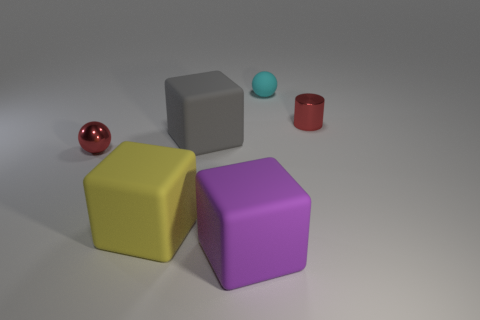Are there the same number of small cylinders left of the large yellow matte object and small red metal balls?
Give a very brief answer. No. What number of yellow matte cubes are to the right of the shiny object on the right side of the red object to the left of the small cyan thing?
Provide a succinct answer. 0. What color is the small object behind the red metal cylinder?
Offer a very short reply. Cyan. There is a block that is both to the right of the yellow matte thing and behind the purple object; what is its material?
Ensure brevity in your answer.  Rubber. There is a small rubber ball behind the big purple matte object; how many cylinders are in front of it?
Offer a very short reply. 1. The big yellow thing has what shape?
Offer a very short reply. Cube. What is the shape of the purple thing that is the same material as the big yellow block?
Keep it short and to the point. Cube. Is the shape of the red metal thing in front of the gray cube the same as  the cyan matte thing?
Your answer should be very brief. Yes. What shape is the metal thing in front of the small red cylinder?
Provide a succinct answer. Sphere. What is the shape of the shiny object that is the same color as the small cylinder?
Make the answer very short. Sphere. 